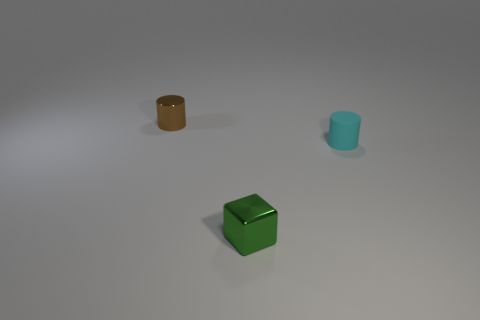There is a cylinder in front of the shiny object to the left of the shiny thing that is to the right of the small metallic cylinder; what is its color?
Your response must be concise. Cyan. There is a metal thing that is to the right of the brown cylinder; does it have the same shape as the brown metallic object?
Offer a very short reply. No. There is a shiny cylinder that is the same size as the green metal block; what color is it?
Provide a succinct answer. Brown. How many small cyan matte cylinders are there?
Your answer should be compact. 1. Does the tiny cylinder that is left of the cyan cylinder have the same material as the small block?
Keep it short and to the point. Yes. What material is the object that is both left of the cyan matte cylinder and behind the green shiny cube?
Ensure brevity in your answer.  Metal. What material is the tiny thing that is in front of the cylinder right of the metallic cylinder?
Ensure brevity in your answer.  Metal. There is a cyan rubber object that is to the right of the small shiny object that is in front of the cylinder that is behind the cyan rubber thing; what is its size?
Your answer should be very brief. Small. What number of small red cylinders have the same material as the green cube?
Offer a terse response. 0. What color is the small cylinder that is behind the small cyan rubber cylinder right of the tiny brown thing?
Your response must be concise. Brown. 